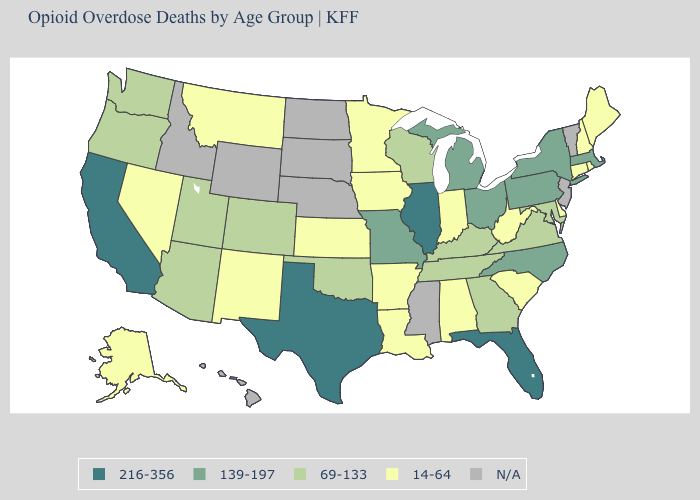Name the states that have a value in the range 216-356?
Quick response, please. California, Florida, Illinois, Texas. What is the highest value in the USA?
Keep it brief. 216-356. What is the value of Colorado?
Give a very brief answer. 69-133. How many symbols are there in the legend?
Quick response, please. 5. What is the lowest value in the West?
Quick response, please. 14-64. Among the states that border Kentucky , does West Virginia have the lowest value?
Be succinct. Yes. Which states have the lowest value in the Northeast?
Be succinct. Connecticut, Maine, New Hampshire, Rhode Island. Name the states that have a value in the range 216-356?
Write a very short answer. California, Florida, Illinois, Texas. Does Colorado have the lowest value in the USA?
Write a very short answer. No. What is the lowest value in states that border Oklahoma?
Answer briefly. 14-64. What is the highest value in states that border Oklahoma?
Quick response, please. 216-356. Name the states that have a value in the range 14-64?
Keep it brief. Alabama, Alaska, Arkansas, Connecticut, Delaware, Indiana, Iowa, Kansas, Louisiana, Maine, Minnesota, Montana, Nevada, New Hampshire, New Mexico, Rhode Island, South Carolina, West Virginia. What is the value of Vermont?
Short answer required. N/A. Among the states that border Mississippi , which have the highest value?
Keep it brief. Tennessee. 